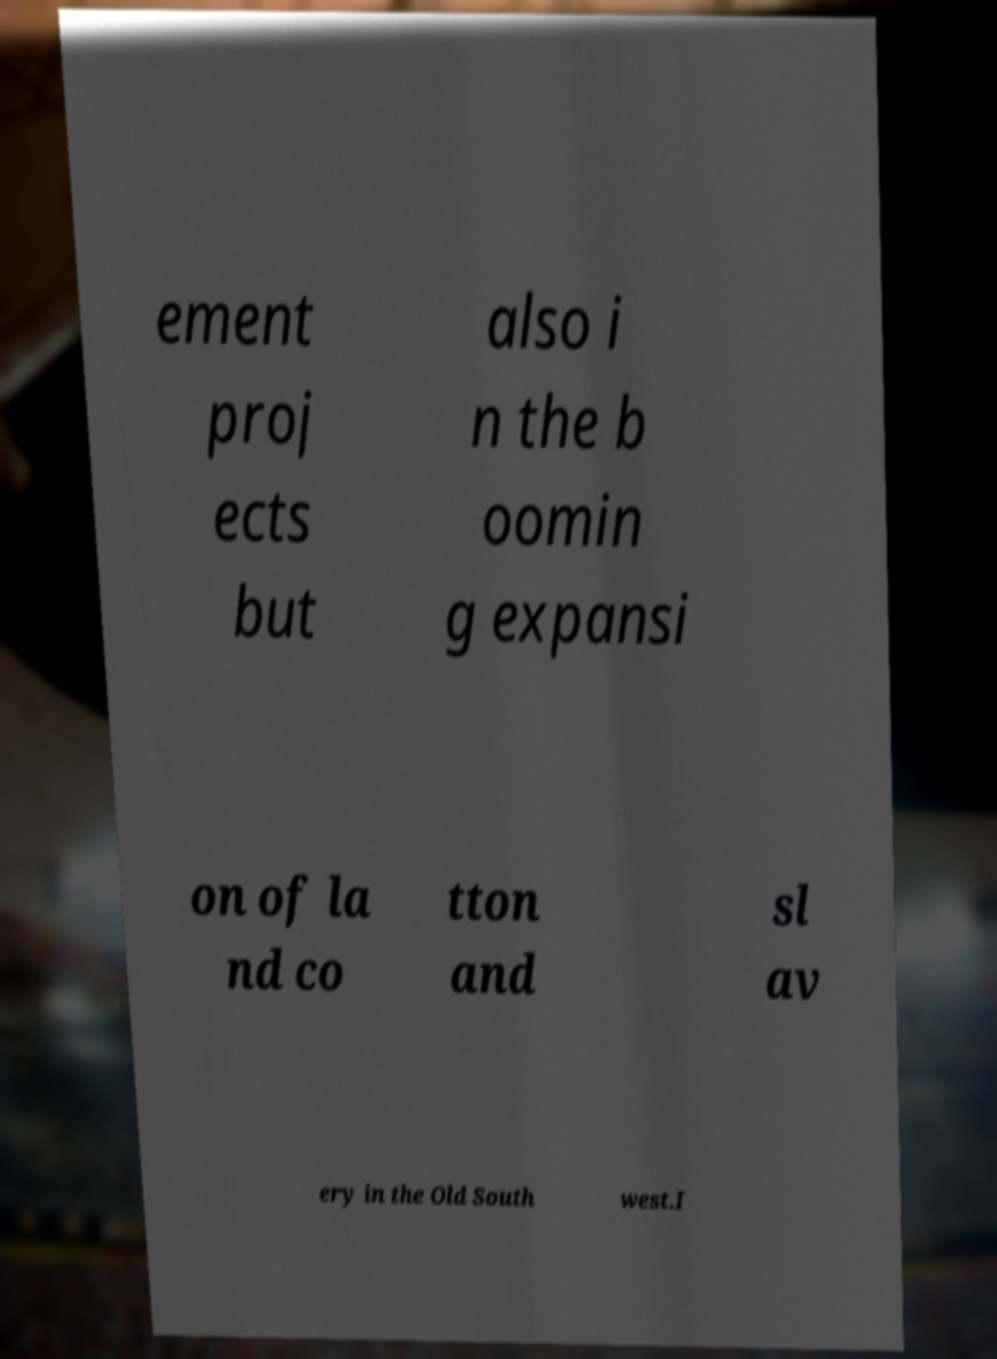Could you extract and type out the text from this image? ement proj ects but also i n the b oomin g expansi on of la nd co tton and sl av ery in the Old South west.I 